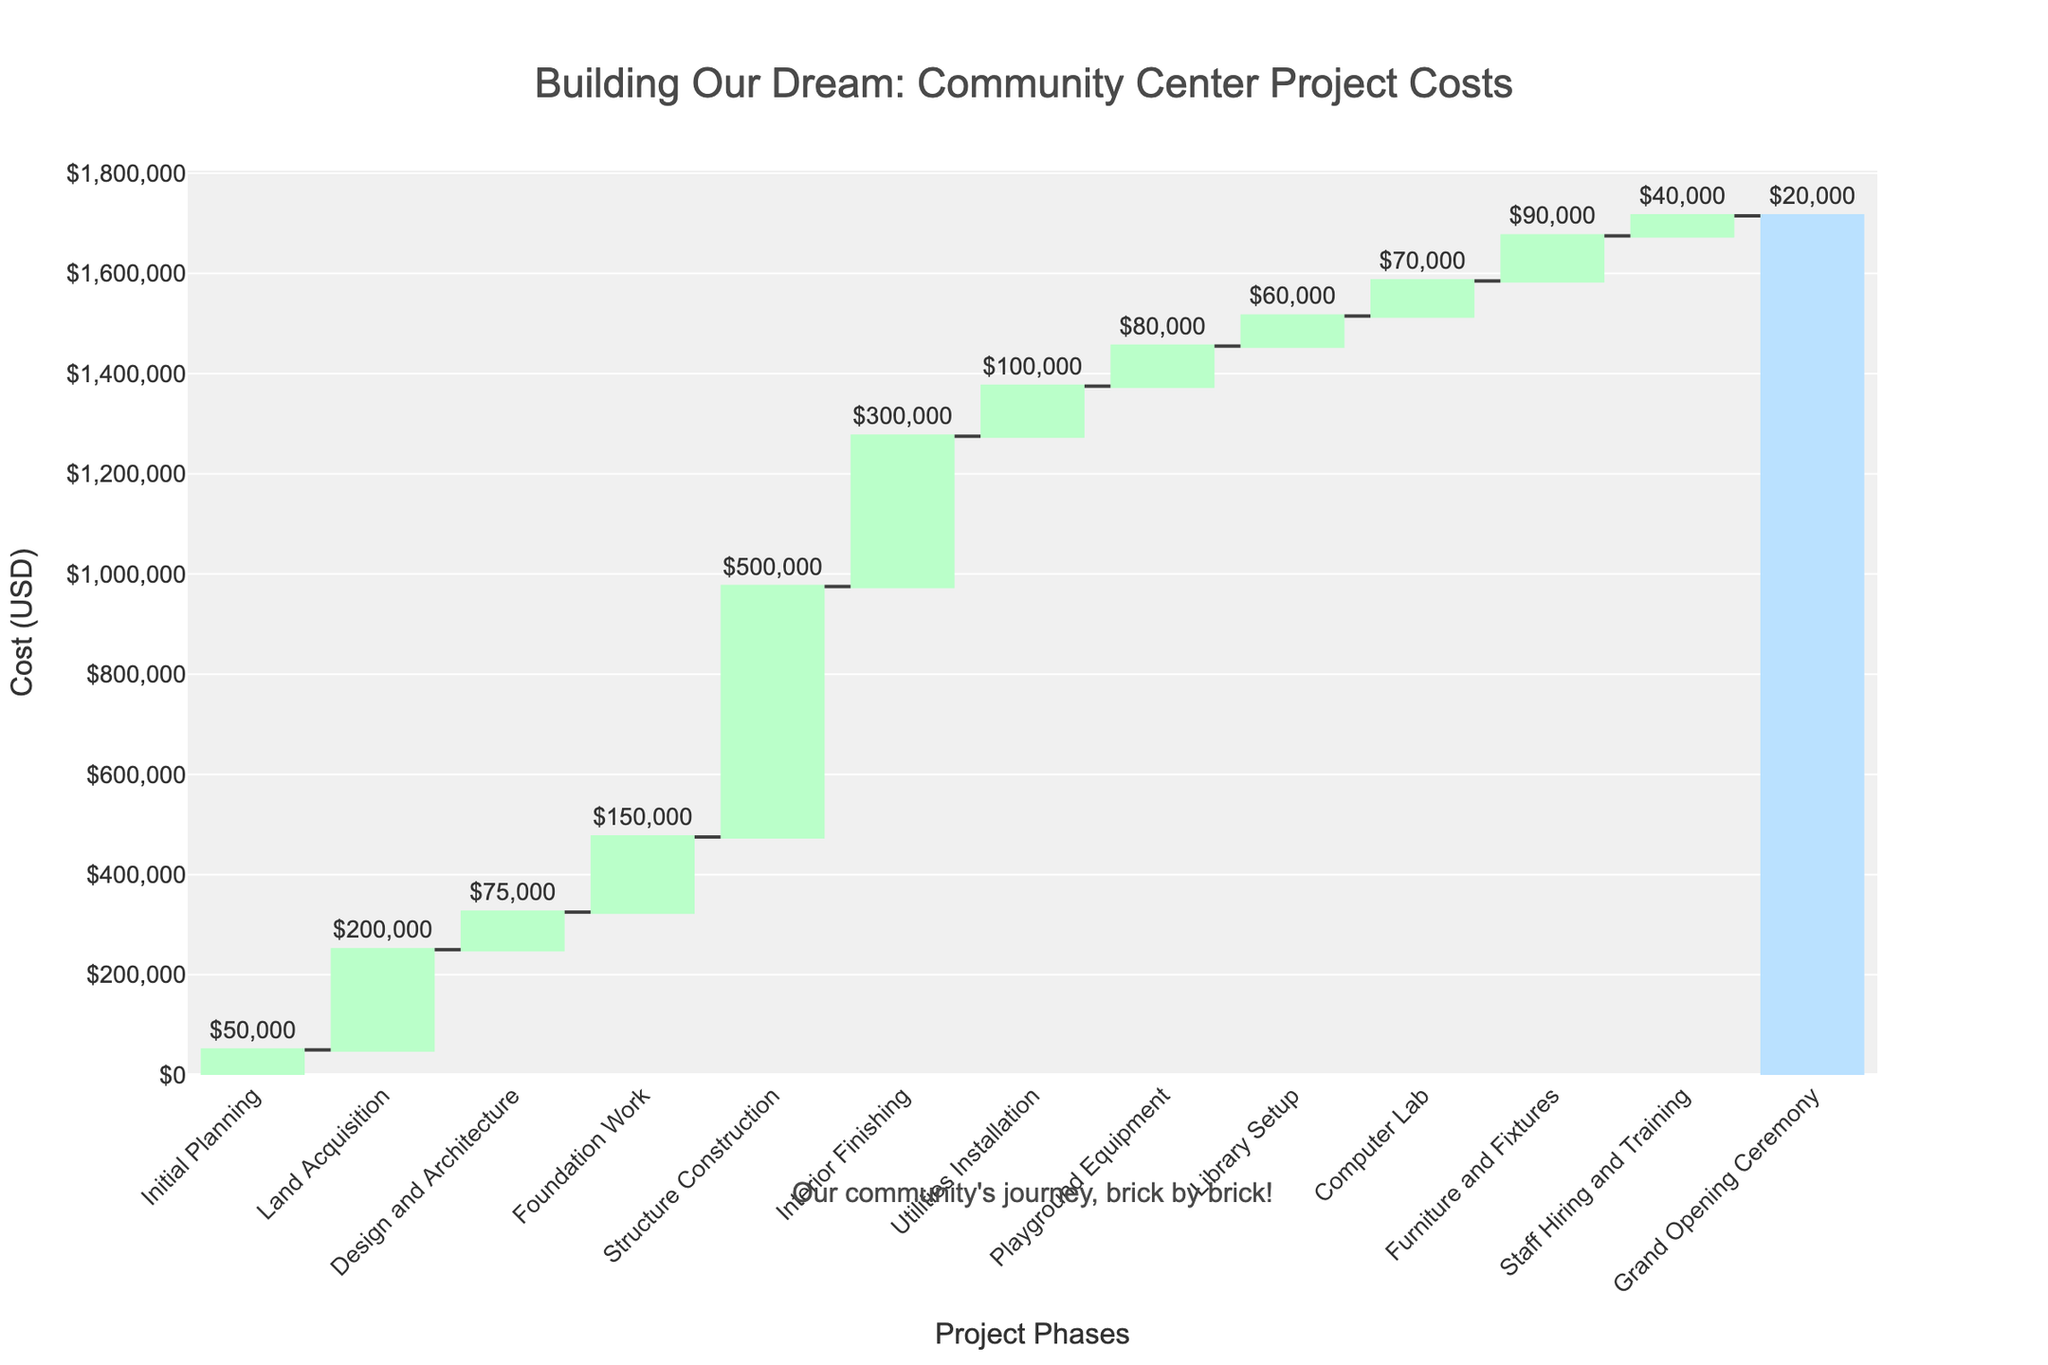What is the title of the chart? The title of the chart is prominently displayed at the top, it reads: "Building Our Dream: Community Center Project Costs"
Answer: Building Our Dream: Community Center Project Costs How many phases are included in the project? By counting the labels along the x-axis, we can see that there are 13 phases included in the project.
Answer: 13 Which phase has the highest cost? The phase that has the highest cost bar (green) is "Structure Construction" with a cost label of $500,000.
Answer: Structure Construction What is the total cost of building the community center? The total cost is indicated by the last bar in the waterfall chart and the cumulative labeling. It is the sum of all the phase costs: $50,000 + $200,000 + $75,000 + $150,000 + $500,000 + $300,000 + $100,000 + $80,000 + $60,000 + $70,000 + $90,000 + $40,000 + $20,000 = $1,735,000.
Answer: $1,735,000 What is the duration for the "Design and Architecture" phase? The duration of the "Design and Architecture" phase is displayed along with other information in the phase detail, it is 3 months.
Answer: 3 months How much more expensive is "Structure Construction" compared to "Foundation Work"? Subtracting the cost of "Foundation Work" ($150,000) from the cost of "Structure Construction" ($500,000) gives the difference: $500,000 - $150,000 = $350,000.
Answer: $350,000 Which phase takes the longest time to complete? The phase with the longest duration can be identified by the largest number of months in the duration labels, which is "Structure Construction" at 6 months.
Answer: Structure Construction What is the ratio of the cost of "Playground Equipment" to "Library Setup"? The cost of "Playground Equipment" is $80,000 and the cost of "Library Setup" is $60,000. Calculating the ratio: $80,000 / $60,000 = 4/3 or approximately 1.33.
Answer: 1.33 Which phases have a duration of less than 1 month? The "Grand Opening Ceremony" phase has a duration listed as 0.5 months, which is less than 1 month.
Answer: Grand Opening Ceremony What is the combined cost of the phases "Interior Finishing" and "Utilities Installation"? Adding the costs of "Interior Finishing" ($300,000) and "Utilities Installation" ($100,000) yields: $300,000 + $100,000 = $400,000.
Answer: $400,000 